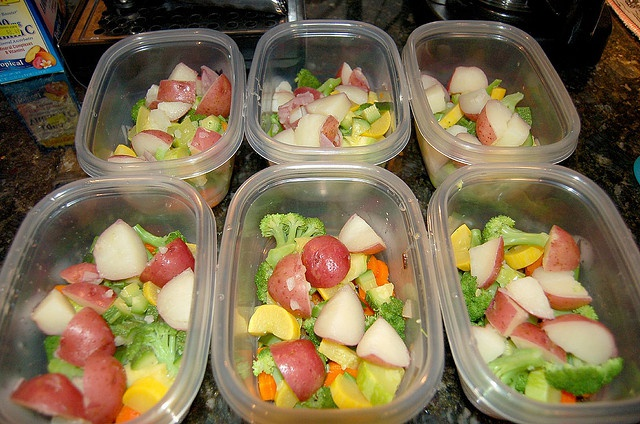Describe the objects in this image and their specific colors. I can see dining table in black, gray, tan, darkgreen, and darkgray tones, bowl in olive, tan, gray, and darkgray tones, bowl in olive, darkgreen, tan, gray, and darkgray tones, bowl in olive, gray, darkgreen, brown, and tan tones, and bowl in olive, gray, black, tan, and darkgray tones in this image. 